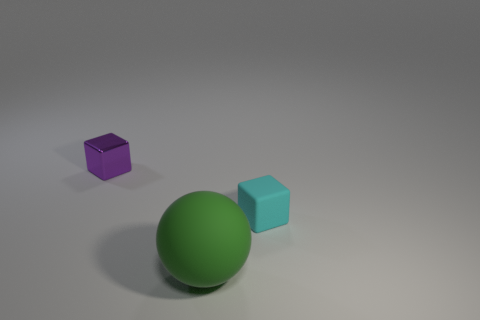Subtract all balls. How many objects are left? 2 Add 1 big balls. How many objects exist? 4 Subtract 2 blocks. How many blocks are left? 0 Subtract all tiny purple objects. Subtract all green rubber spheres. How many objects are left? 1 Add 1 big green matte spheres. How many big green matte spheres are left? 2 Add 2 tiny purple spheres. How many tiny purple spheres exist? 2 Subtract 0 purple balls. How many objects are left? 3 Subtract all red blocks. Subtract all red spheres. How many blocks are left? 2 